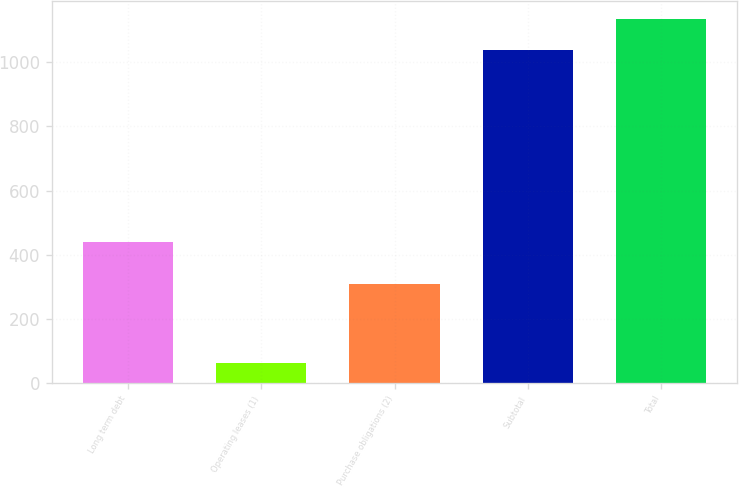<chart> <loc_0><loc_0><loc_500><loc_500><bar_chart><fcel>Long term debt<fcel>Operating leases (1)<fcel>Purchase obligations (2)<fcel>Subtotal<fcel>Total<nl><fcel>440<fcel>62<fcel>310<fcel>1037<fcel>1134.5<nl></chart> 